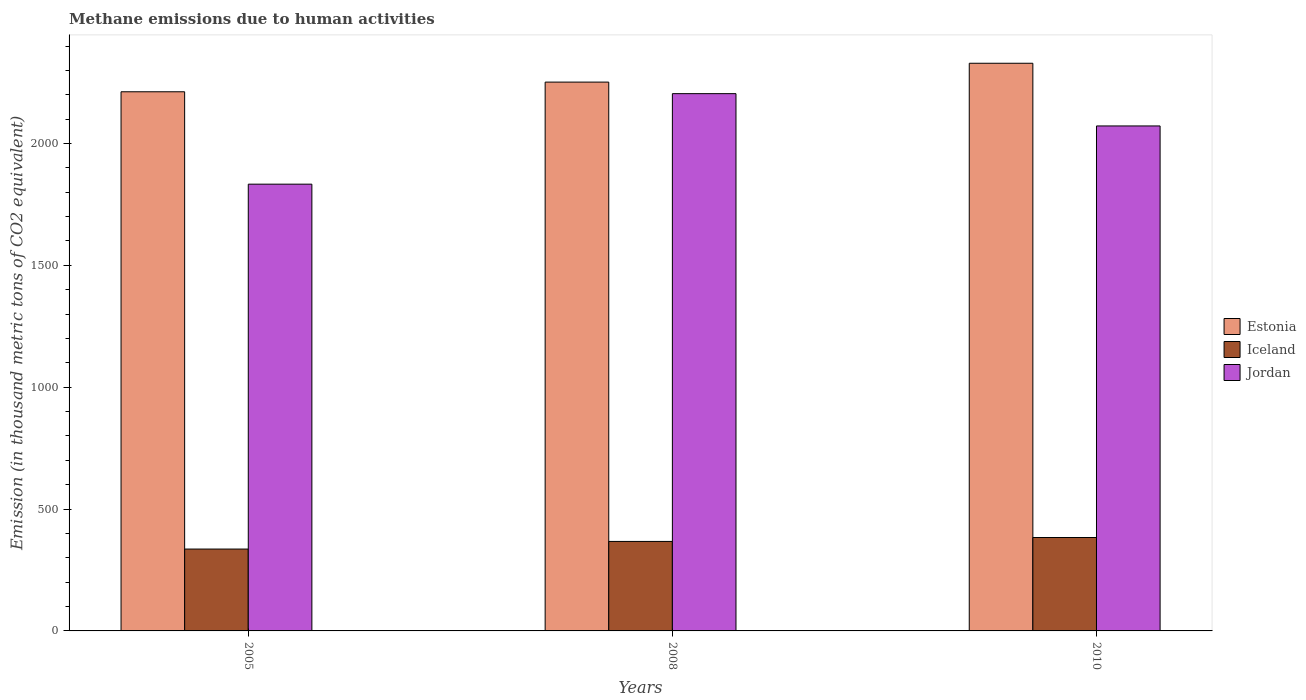How many different coloured bars are there?
Your response must be concise. 3. How many groups of bars are there?
Make the answer very short. 3. Are the number of bars on each tick of the X-axis equal?
Keep it short and to the point. Yes. How many bars are there on the 2nd tick from the right?
Provide a short and direct response. 3. What is the amount of methane emitted in Estonia in 2008?
Offer a very short reply. 2252. Across all years, what is the maximum amount of methane emitted in Jordan?
Offer a terse response. 2204.6. Across all years, what is the minimum amount of methane emitted in Estonia?
Your answer should be compact. 2212.3. In which year was the amount of methane emitted in Iceland maximum?
Give a very brief answer. 2010. In which year was the amount of methane emitted in Iceland minimum?
Make the answer very short. 2005. What is the total amount of methane emitted in Jordan in the graph?
Your answer should be very brief. 6109.9. What is the difference between the amount of methane emitted in Iceland in 2005 and that in 2008?
Ensure brevity in your answer.  -31.3. What is the difference between the amount of methane emitted in Jordan in 2008 and the amount of methane emitted in Iceland in 2010?
Keep it short and to the point. 1821.3. What is the average amount of methane emitted in Jordan per year?
Offer a very short reply. 2036.63. In the year 2010, what is the difference between the amount of methane emitted in Estonia and amount of methane emitted in Iceland?
Your answer should be very brief. 1946. What is the ratio of the amount of methane emitted in Iceland in 2008 to that in 2010?
Provide a succinct answer. 0.96. What is the difference between the highest and the second highest amount of methane emitted in Jordan?
Provide a short and direct response. 132.5. What is the difference between the highest and the lowest amount of methane emitted in Iceland?
Offer a terse response. 47.4. In how many years, is the amount of methane emitted in Jordan greater than the average amount of methane emitted in Jordan taken over all years?
Your answer should be compact. 2. Is the sum of the amount of methane emitted in Estonia in 2005 and 2008 greater than the maximum amount of methane emitted in Iceland across all years?
Your answer should be compact. Yes. What does the 1st bar from the left in 2008 represents?
Keep it short and to the point. Estonia. What does the 1st bar from the right in 2005 represents?
Ensure brevity in your answer.  Jordan. Is it the case that in every year, the sum of the amount of methane emitted in Jordan and amount of methane emitted in Iceland is greater than the amount of methane emitted in Estonia?
Provide a succinct answer. No. How many bars are there?
Your answer should be compact. 9. Does the graph contain grids?
Keep it short and to the point. No. How are the legend labels stacked?
Ensure brevity in your answer.  Vertical. What is the title of the graph?
Your answer should be compact. Methane emissions due to human activities. Does "Guinea" appear as one of the legend labels in the graph?
Offer a very short reply. No. What is the label or title of the X-axis?
Your response must be concise. Years. What is the label or title of the Y-axis?
Your answer should be very brief. Emission (in thousand metric tons of CO2 equivalent). What is the Emission (in thousand metric tons of CO2 equivalent) in Estonia in 2005?
Your response must be concise. 2212.3. What is the Emission (in thousand metric tons of CO2 equivalent) in Iceland in 2005?
Provide a short and direct response. 335.9. What is the Emission (in thousand metric tons of CO2 equivalent) in Jordan in 2005?
Provide a succinct answer. 1833.2. What is the Emission (in thousand metric tons of CO2 equivalent) in Estonia in 2008?
Your answer should be compact. 2252. What is the Emission (in thousand metric tons of CO2 equivalent) of Iceland in 2008?
Keep it short and to the point. 367.2. What is the Emission (in thousand metric tons of CO2 equivalent) of Jordan in 2008?
Keep it short and to the point. 2204.6. What is the Emission (in thousand metric tons of CO2 equivalent) in Estonia in 2010?
Ensure brevity in your answer.  2329.3. What is the Emission (in thousand metric tons of CO2 equivalent) of Iceland in 2010?
Ensure brevity in your answer.  383.3. What is the Emission (in thousand metric tons of CO2 equivalent) of Jordan in 2010?
Offer a very short reply. 2072.1. Across all years, what is the maximum Emission (in thousand metric tons of CO2 equivalent) of Estonia?
Provide a succinct answer. 2329.3. Across all years, what is the maximum Emission (in thousand metric tons of CO2 equivalent) of Iceland?
Your answer should be compact. 383.3. Across all years, what is the maximum Emission (in thousand metric tons of CO2 equivalent) in Jordan?
Offer a very short reply. 2204.6. Across all years, what is the minimum Emission (in thousand metric tons of CO2 equivalent) of Estonia?
Ensure brevity in your answer.  2212.3. Across all years, what is the minimum Emission (in thousand metric tons of CO2 equivalent) in Iceland?
Your answer should be very brief. 335.9. Across all years, what is the minimum Emission (in thousand metric tons of CO2 equivalent) in Jordan?
Offer a very short reply. 1833.2. What is the total Emission (in thousand metric tons of CO2 equivalent) in Estonia in the graph?
Give a very brief answer. 6793.6. What is the total Emission (in thousand metric tons of CO2 equivalent) of Iceland in the graph?
Your answer should be very brief. 1086.4. What is the total Emission (in thousand metric tons of CO2 equivalent) of Jordan in the graph?
Keep it short and to the point. 6109.9. What is the difference between the Emission (in thousand metric tons of CO2 equivalent) of Estonia in 2005 and that in 2008?
Keep it short and to the point. -39.7. What is the difference between the Emission (in thousand metric tons of CO2 equivalent) of Iceland in 2005 and that in 2008?
Keep it short and to the point. -31.3. What is the difference between the Emission (in thousand metric tons of CO2 equivalent) in Jordan in 2005 and that in 2008?
Give a very brief answer. -371.4. What is the difference between the Emission (in thousand metric tons of CO2 equivalent) of Estonia in 2005 and that in 2010?
Give a very brief answer. -117. What is the difference between the Emission (in thousand metric tons of CO2 equivalent) of Iceland in 2005 and that in 2010?
Your answer should be compact. -47.4. What is the difference between the Emission (in thousand metric tons of CO2 equivalent) in Jordan in 2005 and that in 2010?
Offer a very short reply. -238.9. What is the difference between the Emission (in thousand metric tons of CO2 equivalent) in Estonia in 2008 and that in 2010?
Give a very brief answer. -77.3. What is the difference between the Emission (in thousand metric tons of CO2 equivalent) in Iceland in 2008 and that in 2010?
Give a very brief answer. -16.1. What is the difference between the Emission (in thousand metric tons of CO2 equivalent) of Jordan in 2008 and that in 2010?
Your answer should be compact. 132.5. What is the difference between the Emission (in thousand metric tons of CO2 equivalent) in Estonia in 2005 and the Emission (in thousand metric tons of CO2 equivalent) in Iceland in 2008?
Keep it short and to the point. 1845.1. What is the difference between the Emission (in thousand metric tons of CO2 equivalent) in Estonia in 2005 and the Emission (in thousand metric tons of CO2 equivalent) in Jordan in 2008?
Offer a very short reply. 7.7. What is the difference between the Emission (in thousand metric tons of CO2 equivalent) in Iceland in 2005 and the Emission (in thousand metric tons of CO2 equivalent) in Jordan in 2008?
Keep it short and to the point. -1868.7. What is the difference between the Emission (in thousand metric tons of CO2 equivalent) of Estonia in 2005 and the Emission (in thousand metric tons of CO2 equivalent) of Iceland in 2010?
Offer a terse response. 1829. What is the difference between the Emission (in thousand metric tons of CO2 equivalent) in Estonia in 2005 and the Emission (in thousand metric tons of CO2 equivalent) in Jordan in 2010?
Your answer should be very brief. 140.2. What is the difference between the Emission (in thousand metric tons of CO2 equivalent) of Iceland in 2005 and the Emission (in thousand metric tons of CO2 equivalent) of Jordan in 2010?
Your answer should be compact. -1736.2. What is the difference between the Emission (in thousand metric tons of CO2 equivalent) of Estonia in 2008 and the Emission (in thousand metric tons of CO2 equivalent) of Iceland in 2010?
Give a very brief answer. 1868.7. What is the difference between the Emission (in thousand metric tons of CO2 equivalent) of Estonia in 2008 and the Emission (in thousand metric tons of CO2 equivalent) of Jordan in 2010?
Make the answer very short. 179.9. What is the difference between the Emission (in thousand metric tons of CO2 equivalent) in Iceland in 2008 and the Emission (in thousand metric tons of CO2 equivalent) in Jordan in 2010?
Provide a succinct answer. -1704.9. What is the average Emission (in thousand metric tons of CO2 equivalent) of Estonia per year?
Give a very brief answer. 2264.53. What is the average Emission (in thousand metric tons of CO2 equivalent) in Iceland per year?
Provide a succinct answer. 362.13. What is the average Emission (in thousand metric tons of CO2 equivalent) in Jordan per year?
Your response must be concise. 2036.63. In the year 2005, what is the difference between the Emission (in thousand metric tons of CO2 equivalent) of Estonia and Emission (in thousand metric tons of CO2 equivalent) of Iceland?
Give a very brief answer. 1876.4. In the year 2005, what is the difference between the Emission (in thousand metric tons of CO2 equivalent) of Estonia and Emission (in thousand metric tons of CO2 equivalent) of Jordan?
Make the answer very short. 379.1. In the year 2005, what is the difference between the Emission (in thousand metric tons of CO2 equivalent) in Iceland and Emission (in thousand metric tons of CO2 equivalent) in Jordan?
Give a very brief answer. -1497.3. In the year 2008, what is the difference between the Emission (in thousand metric tons of CO2 equivalent) in Estonia and Emission (in thousand metric tons of CO2 equivalent) in Iceland?
Your answer should be compact. 1884.8. In the year 2008, what is the difference between the Emission (in thousand metric tons of CO2 equivalent) of Estonia and Emission (in thousand metric tons of CO2 equivalent) of Jordan?
Offer a terse response. 47.4. In the year 2008, what is the difference between the Emission (in thousand metric tons of CO2 equivalent) of Iceland and Emission (in thousand metric tons of CO2 equivalent) of Jordan?
Offer a very short reply. -1837.4. In the year 2010, what is the difference between the Emission (in thousand metric tons of CO2 equivalent) in Estonia and Emission (in thousand metric tons of CO2 equivalent) in Iceland?
Your response must be concise. 1946. In the year 2010, what is the difference between the Emission (in thousand metric tons of CO2 equivalent) of Estonia and Emission (in thousand metric tons of CO2 equivalent) of Jordan?
Your answer should be very brief. 257.2. In the year 2010, what is the difference between the Emission (in thousand metric tons of CO2 equivalent) of Iceland and Emission (in thousand metric tons of CO2 equivalent) of Jordan?
Ensure brevity in your answer.  -1688.8. What is the ratio of the Emission (in thousand metric tons of CO2 equivalent) in Estonia in 2005 to that in 2008?
Your answer should be compact. 0.98. What is the ratio of the Emission (in thousand metric tons of CO2 equivalent) of Iceland in 2005 to that in 2008?
Offer a very short reply. 0.91. What is the ratio of the Emission (in thousand metric tons of CO2 equivalent) of Jordan in 2005 to that in 2008?
Ensure brevity in your answer.  0.83. What is the ratio of the Emission (in thousand metric tons of CO2 equivalent) in Estonia in 2005 to that in 2010?
Offer a very short reply. 0.95. What is the ratio of the Emission (in thousand metric tons of CO2 equivalent) of Iceland in 2005 to that in 2010?
Your answer should be compact. 0.88. What is the ratio of the Emission (in thousand metric tons of CO2 equivalent) of Jordan in 2005 to that in 2010?
Provide a short and direct response. 0.88. What is the ratio of the Emission (in thousand metric tons of CO2 equivalent) of Estonia in 2008 to that in 2010?
Keep it short and to the point. 0.97. What is the ratio of the Emission (in thousand metric tons of CO2 equivalent) in Iceland in 2008 to that in 2010?
Your answer should be compact. 0.96. What is the ratio of the Emission (in thousand metric tons of CO2 equivalent) in Jordan in 2008 to that in 2010?
Provide a succinct answer. 1.06. What is the difference between the highest and the second highest Emission (in thousand metric tons of CO2 equivalent) of Estonia?
Provide a short and direct response. 77.3. What is the difference between the highest and the second highest Emission (in thousand metric tons of CO2 equivalent) in Iceland?
Provide a succinct answer. 16.1. What is the difference between the highest and the second highest Emission (in thousand metric tons of CO2 equivalent) in Jordan?
Offer a terse response. 132.5. What is the difference between the highest and the lowest Emission (in thousand metric tons of CO2 equivalent) in Estonia?
Your answer should be compact. 117. What is the difference between the highest and the lowest Emission (in thousand metric tons of CO2 equivalent) in Iceland?
Offer a very short reply. 47.4. What is the difference between the highest and the lowest Emission (in thousand metric tons of CO2 equivalent) of Jordan?
Your answer should be very brief. 371.4. 